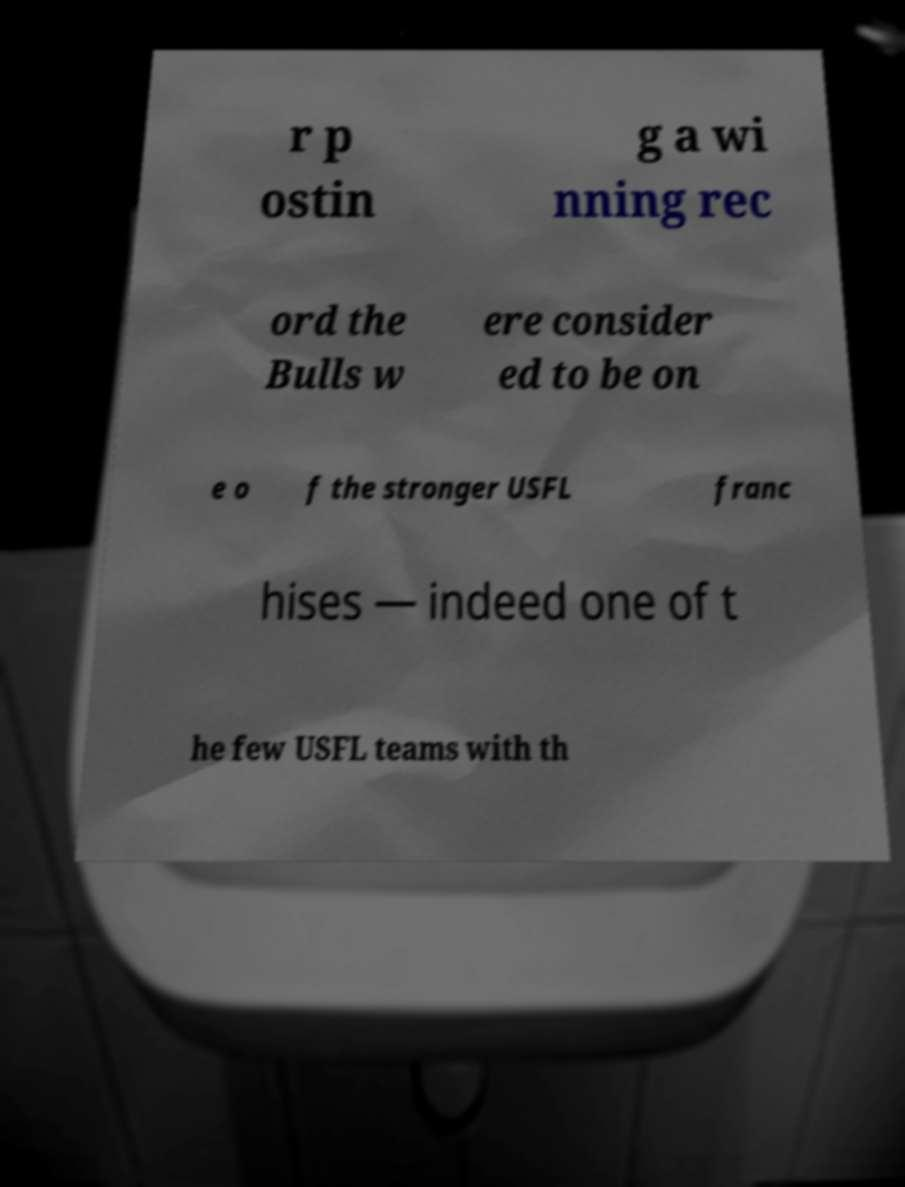What messages or text are displayed in this image? I need them in a readable, typed format. r p ostin g a wi nning rec ord the Bulls w ere consider ed to be on e o f the stronger USFL franc hises — indeed one of t he few USFL teams with th 